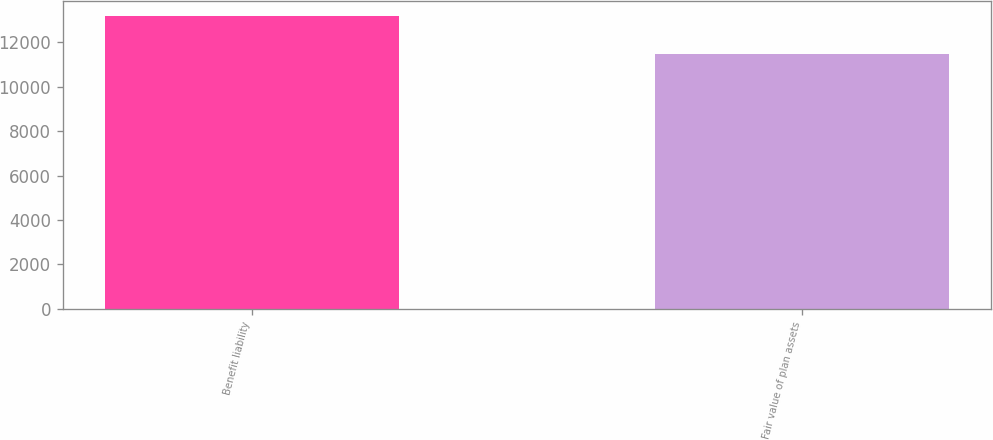Convert chart to OTSL. <chart><loc_0><loc_0><loc_500><loc_500><bar_chart><fcel>Benefit liability<fcel>Fair value of plan assets<nl><fcel>13192<fcel>11458<nl></chart> 